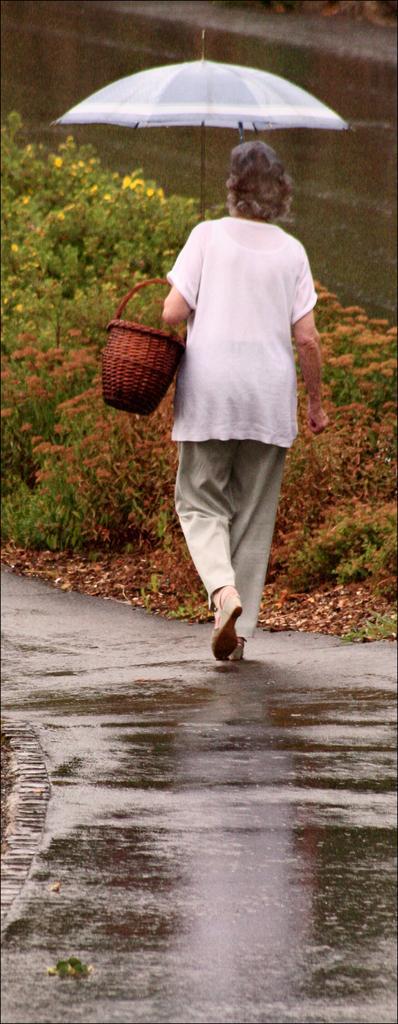Can you describe this image briefly? In this image there is a woman holding a basket and an umbrella walking on a road, in the background there are plants. 